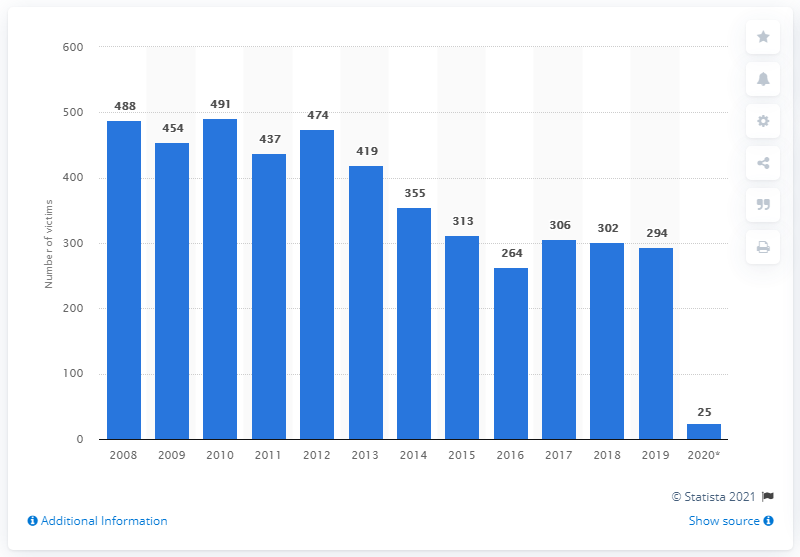Highlight a few significant elements in this photo. A total of 25 work-related death cases were reported in Italy between January and February 3rd, 2020, as reported by the press. In 2008, a total of 488 work-related deaths were reported by the press. In 2019, a total of 294 work-related deaths were reported by the press. 